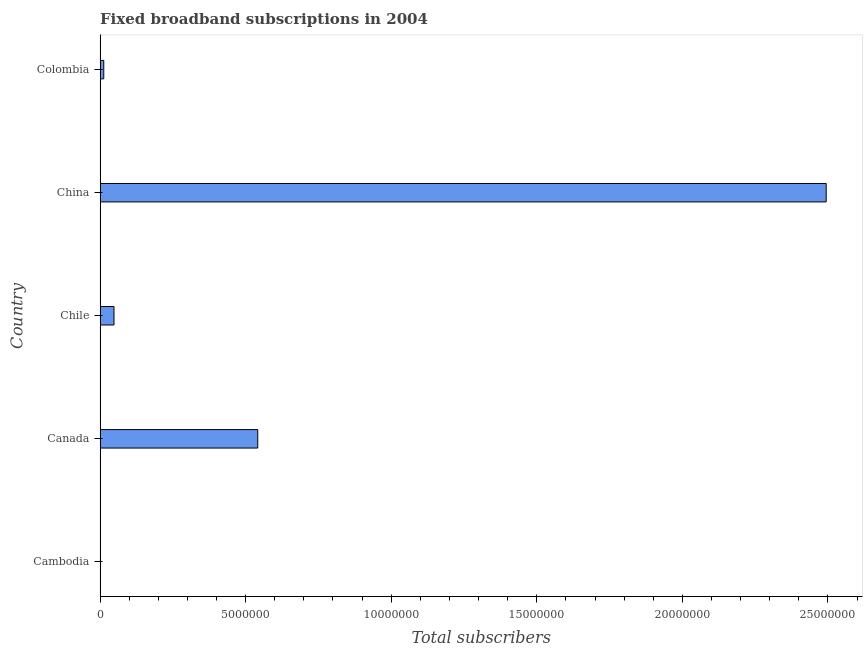Does the graph contain any zero values?
Your answer should be very brief. No. Does the graph contain grids?
Make the answer very short. No. What is the title of the graph?
Give a very brief answer. Fixed broadband subscriptions in 2004. What is the label or title of the X-axis?
Provide a succinct answer. Total subscribers. What is the total number of fixed broadband subscriptions in China?
Your answer should be compact. 2.49e+07. Across all countries, what is the maximum total number of fixed broadband subscriptions?
Keep it short and to the point. 2.49e+07. Across all countries, what is the minimum total number of fixed broadband subscriptions?
Make the answer very short. 780. In which country was the total number of fixed broadband subscriptions minimum?
Offer a terse response. Cambodia. What is the sum of the total number of fixed broadband subscriptions?
Offer a very short reply. 3.10e+07. What is the difference between the total number of fixed broadband subscriptions in Chile and Colombia?
Provide a short and direct response. 3.52e+05. What is the average total number of fixed broadband subscriptions per country?
Provide a succinct answer. 6.19e+06. What is the median total number of fixed broadband subscriptions?
Offer a terse response. 4.79e+05. What is the ratio of the total number of fixed broadband subscriptions in Cambodia to that in China?
Give a very brief answer. 0. Is the total number of fixed broadband subscriptions in Canada less than that in Chile?
Offer a terse response. No. Is the difference between the total number of fixed broadband subscriptions in Cambodia and Canada greater than the difference between any two countries?
Your response must be concise. No. What is the difference between the highest and the second highest total number of fixed broadband subscriptions?
Provide a succinct answer. 1.95e+07. Is the sum of the total number of fixed broadband subscriptions in Canada and Colombia greater than the maximum total number of fixed broadband subscriptions across all countries?
Offer a terse response. No. What is the difference between the highest and the lowest total number of fixed broadband subscriptions?
Give a very brief answer. 2.49e+07. How many bars are there?
Your answer should be compact. 5. How many countries are there in the graph?
Keep it short and to the point. 5. What is the Total subscribers of Cambodia?
Provide a succinct answer. 780. What is the Total subscribers of Canada?
Your answer should be very brief. 5.42e+06. What is the Total subscribers of Chile?
Provide a short and direct response. 4.79e+05. What is the Total subscribers of China?
Provide a succinct answer. 2.49e+07. What is the Total subscribers of Colombia?
Keep it short and to the point. 1.27e+05. What is the difference between the Total subscribers in Cambodia and Canada?
Provide a short and direct response. -5.42e+06. What is the difference between the Total subscribers in Cambodia and Chile?
Offer a very short reply. -4.78e+05. What is the difference between the Total subscribers in Cambodia and China?
Offer a terse response. -2.49e+07. What is the difference between the Total subscribers in Cambodia and Colombia?
Provide a succinct answer. -1.26e+05. What is the difference between the Total subscribers in Canada and Chile?
Your answer should be very brief. 4.94e+06. What is the difference between the Total subscribers in Canada and China?
Make the answer very short. -1.95e+07. What is the difference between the Total subscribers in Canada and Colombia?
Keep it short and to the point. 5.29e+06. What is the difference between the Total subscribers in Chile and China?
Offer a terse response. -2.45e+07. What is the difference between the Total subscribers in Chile and Colombia?
Your response must be concise. 3.52e+05. What is the difference between the Total subscribers in China and Colombia?
Your response must be concise. 2.48e+07. What is the ratio of the Total subscribers in Cambodia to that in Chile?
Your answer should be very brief. 0. What is the ratio of the Total subscribers in Cambodia to that in China?
Provide a short and direct response. 0. What is the ratio of the Total subscribers in Cambodia to that in Colombia?
Give a very brief answer. 0.01. What is the ratio of the Total subscribers in Canada to that in Chile?
Your answer should be very brief. 11.31. What is the ratio of the Total subscribers in Canada to that in China?
Offer a very short reply. 0.22. What is the ratio of the Total subscribers in Canada to that in Colombia?
Offer a very short reply. 42.61. What is the ratio of the Total subscribers in Chile to that in China?
Your response must be concise. 0.02. What is the ratio of the Total subscribers in Chile to that in Colombia?
Make the answer very short. 3.77. What is the ratio of the Total subscribers in China to that in Colombia?
Provide a succinct answer. 196.2. 